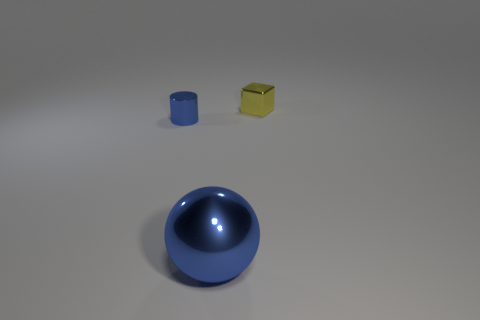What is the shape of the other shiny thing that is the same color as the large object?
Your answer should be compact. Cylinder. What is the material of the thing that is to the left of the blue object in front of the tiny shiny thing that is on the left side of the big blue metal ball?
Provide a succinct answer. Metal. There is a blue metal ball; is it the same size as the metallic object that is behind the cylinder?
Make the answer very short. No. There is a metallic object that is behind the tiny shiny thing that is on the left side of the thing behind the cylinder; what size is it?
Provide a succinct answer. Small. Does the blue metallic cylinder have the same size as the sphere?
Make the answer very short. No. There is a small thing to the left of the tiny yellow metallic object behind the large blue shiny thing; what is it made of?
Your answer should be compact. Metal. Is the shape of the tiny metal thing that is behind the small blue cylinder the same as the metallic thing to the left of the big metal sphere?
Provide a succinct answer. No. Are there the same number of spheres that are behind the large metallic sphere and big purple shiny things?
Ensure brevity in your answer.  Yes. Is there a small cylinder right of the blue object that is left of the big object?
Keep it short and to the point. No. Is there any other thing that is the same color as the small cylinder?
Keep it short and to the point. Yes. 